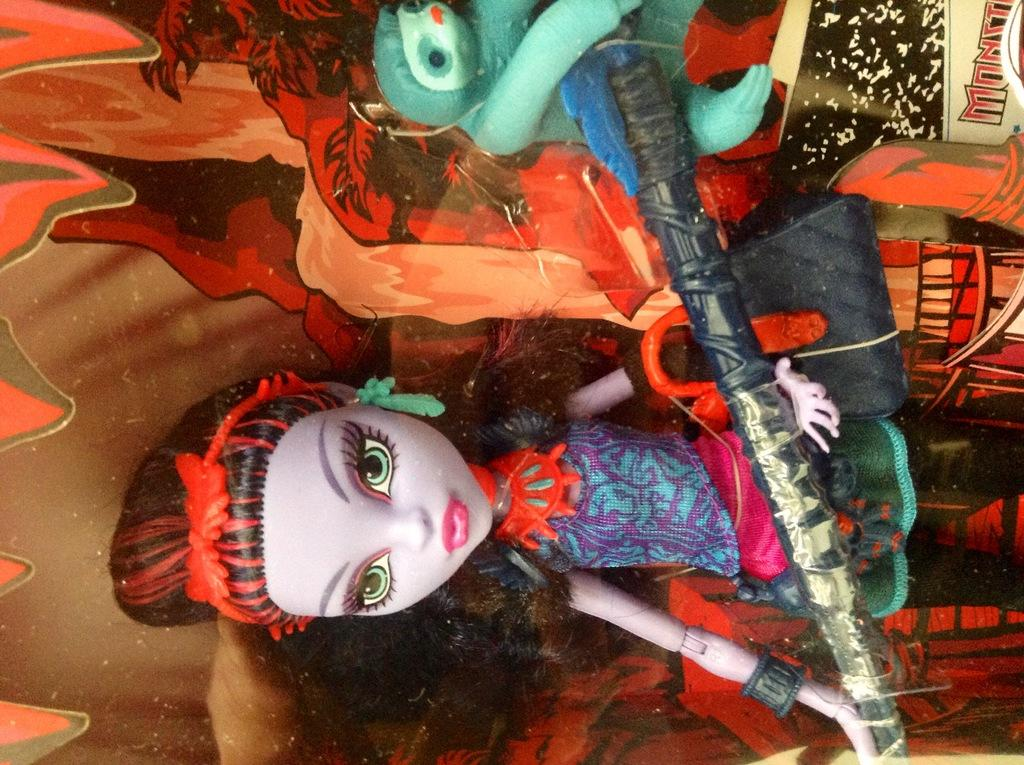What is the main subject of the image? There is a doll in the image. How does the fog affect the visibility of the doll in the image? There is no fog present in the image, so it does not affect the visibility of the doll. What type of ball is being held by the doll in the image? There is no ball present in the image; the doll is the only subject mentioned in the provided fact. 